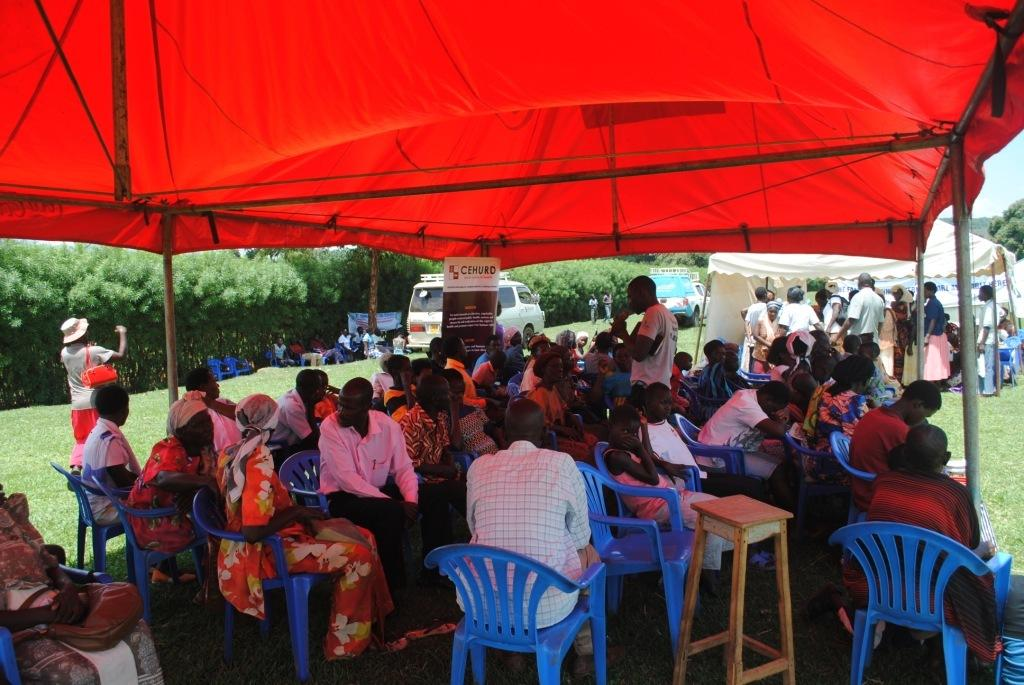What are the people in the image doing? There are people sitting under tents in the image. Are there any people standing in the image? Yes, some people are standing in the image. What can be seen in the background of the image? There are trees and vehicles in the background of the image. What type of honey is being served to the people in the image? There is no honey present in the image. What fruit can be seen on the table in the image? There is no fruit visible in the image. 